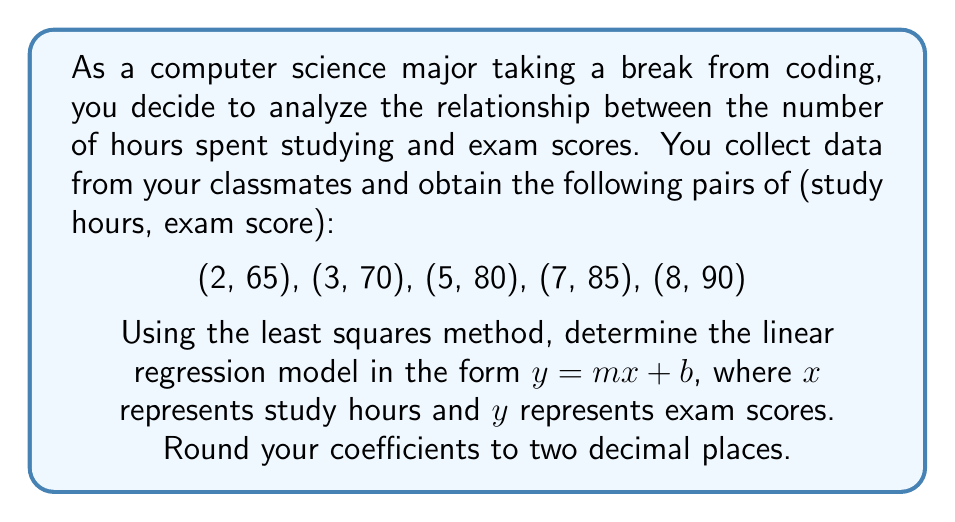Can you solve this math problem? Let's approach this step-by-step using the least squares method:

1) We need to calculate the following sums:
   $\sum x$, $\sum y$, $\sum xy$, $\sum x^2$

2) Calculate each sum:
   $\sum x = 2 + 3 + 5 + 7 + 8 = 25$
   $\sum y = 65 + 70 + 80 + 85 + 90 = 390$
   $\sum xy = (2 * 65) + (3 * 70) + (5 * 80) + (7 * 85) + (8 * 90) = 2075$
   $\sum x^2 = 2^2 + 3^2 + 5^2 + 7^2 + 8^2 = 147$

3) We have 5 data points, so $n = 5$

4) Use these formulas to calculate $m$ and $b$:

   $m = \frac{n\sum xy - \sum x \sum y}{n\sum x^2 - (\sum x)^2}$

   $b = \frac{\sum y - m\sum x}{n}$

5) Substitute the values:

   $m = \frac{5(2075) - (25)(390)}{5(147) - (25)^2}$
      $= \frac{10375 - 9750}{735 - 625}$
      $= \frac{625}{110}$
      $\approx 5.68$

   $b = \frac{390 - 5.68(25)}{5}$
      $= \frac{390 - 142}{5}$
      $= \frac{248}{5}$
      $\approx 49.60$

6) Therefore, the linear regression model is:
   $y = 5.68x + 49.60$
Answer: $y = 5.68x + 49.60$ 